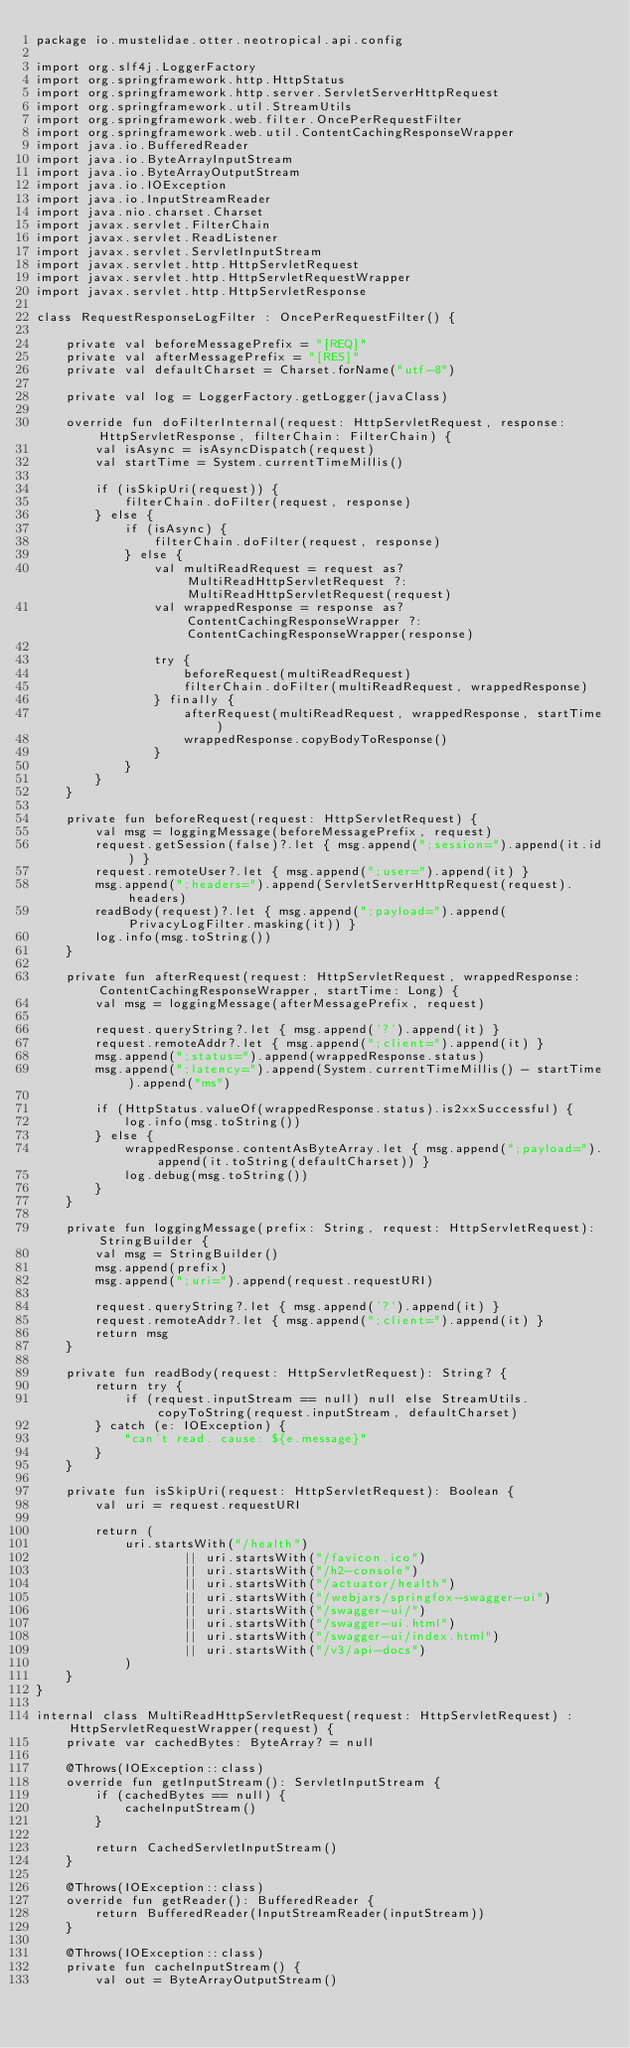Convert code to text. <code><loc_0><loc_0><loc_500><loc_500><_Kotlin_>package io.mustelidae.otter.neotropical.api.config

import org.slf4j.LoggerFactory
import org.springframework.http.HttpStatus
import org.springframework.http.server.ServletServerHttpRequest
import org.springframework.util.StreamUtils
import org.springframework.web.filter.OncePerRequestFilter
import org.springframework.web.util.ContentCachingResponseWrapper
import java.io.BufferedReader
import java.io.ByteArrayInputStream
import java.io.ByteArrayOutputStream
import java.io.IOException
import java.io.InputStreamReader
import java.nio.charset.Charset
import javax.servlet.FilterChain
import javax.servlet.ReadListener
import javax.servlet.ServletInputStream
import javax.servlet.http.HttpServletRequest
import javax.servlet.http.HttpServletRequestWrapper
import javax.servlet.http.HttpServletResponse

class RequestResponseLogFilter : OncePerRequestFilter() {

    private val beforeMessagePrefix = "[REQ]"
    private val afterMessagePrefix = "[RES]"
    private val defaultCharset = Charset.forName("utf-8")

    private val log = LoggerFactory.getLogger(javaClass)

    override fun doFilterInternal(request: HttpServletRequest, response: HttpServletResponse, filterChain: FilterChain) {
        val isAsync = isAsyncDispatch(request)
        val startTime = System.currentTimeMillis()

        if (isSkipUri(request)) {
            filterChain.doFilter(request, response)
        } else {
            if (isAsync) {
                filterChain.doFilter(request, response)
            } else {
                val multiReadRequest = request as? MultiReadHttpServletRequest ?: MultiReadHttpServletRequest(request)
                val wrappedResponse = response as? ContentCachingResponseWrapper ?: ContentCachingResponseWrapper(response)

                try {
                    beforeRequest(multiReadRequest)
                    filterChain.doFilter(multiReadRequest, wrappedResponse)
                } finally {
                    afterRequest(multiReadRequest, wrappedResponse, startTime)
                    wrappedResponse.copyBodyToResponse()
                }
            }
        }
    }

    private fun beforeRequest(request: HttpServletRequest) {
        val msg = loggingMessage(beforeMessagePrefix, request)
        request.getSession(false)?.let { msg.append(";session=").append(it.id) }
        request.remoteUser?.let { msg.append(";user=").append(it) }
        msg.append(";headers=").append(ServletServerHttpRequest(request).headers)
        readBody(request)?.let { msg.append(";payload=").append(PrivacyLogFilter.masking(it)) }
        log.info(msg.toString())
    }

    private fun afterRequest(request: HttpServletRequest, wrappedResponse: ContentCachingResponseWrapper, startTime: Long) {
        val msg = loggingMessage(afterMessagePrefix, request)

        request.queryString?.let { msg.append('?').append(it) }
        request.remoteAddr?.let { msg.append(";client=").append(it) }
        msg.append(";status=").append(wrappedResponse.status)
        msg.append(";latency=").append(System.currentTimeMillis() - startTime).append("ms")

        if (HttpStatus.valueOf(wrappedResponse.status).is2xxSuccessful) {
            log.info(msg.toString())
        } else {
            wrappedResponse.contentAsByteArray.let { msg.append(";payload=").append(it.toString(defaultCharset)) }
            log.debug(msg.toString())
        }
    }

    private fun loggingMessage(prefix: String, request: HttpServletRequest): StringBuilder {
        val msg = StringBuilder()
        msg.append(prefix)
        msg.append(";uri=").append(request.requestURI)

        request.queryString?.let { msg.append('?').append(it) }
        request.remoteAddr?.let { msg.append(";client=").append(it) }
        return msg
    }

    private fun readBody(request: HttpServletRequest): String? {
        return try {
            if (request.inputStream == null) null else StreamUtils.copyToString(request.inputStream, defaultCharset)
        } catch (e: IOException) {
            "can't read. cause: ${e.message}"
        }
    }

    private fun isSkipUri(request: HttpServletRequest): Boolean {
        val uri = request.requestURI

        return (
            uri.startsWith("/health")
                    || uri.startsWith("/favicon.ico")
                    || uri.startsWith("/h2-console")
                    || uri.startsWith("/actuator/health")
                    || uri.startsWith("/webjars/springfox-swagger-ui")
                    || uri.startsWith("/swagger-ui/")
                    || uri.startsWith("/swagger-ui.html")
                    || uri.startsWith("/swagger-ui/index.html")
                    || uri.startsWith("/v3/api-docs")
            )
    }
}

internal class MultiReadHttpServletRequest(request: HttpServletRequest) : HttpServletRequestWrapper(request) {
    private var cachedBytes: ByteArray? = null

    @Throws(IOException::class)
    override fun getInputStream(): ServletInputStream {
        if (cachedBytes == null) {
            cacheInputStream()
        }

        return CachedServletInputStream()
    }

    @Throws(IOException::class)
    override fun getReader(): BufferedReader {
        return BufferedReader(InputStreamReader(inputStream))
    }

    @Throws(IOException::class)
    private fun cacheInputStream() {
        val out = ByteArrayOutputStream()
</code> 